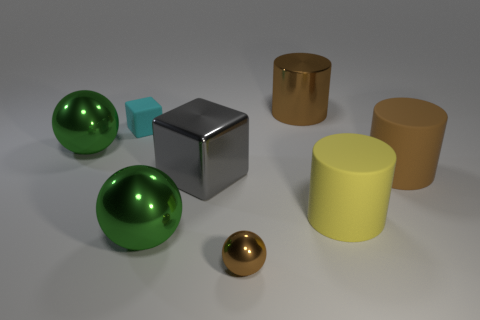Is the big brown cylinder that is in front of the large shiny cylinder made of the same material as the tiny brown thing in front of the tiny rubber object?
Your answer should be very brief. No. There is a large cylinder behind the thing right of the yellow object; what is it made of?
Offer a terse response. Metal. There is a large sphere that is in front of the brown rubber cylinder; what is its material?
Provide a short and direct response. Metal. How many large green objects are the same shape as the big gray shiny thing?
Your answer should be compact. 0. Is the color of the big metal cylinder the same as the small metallic thing?
Make the answer very short. Yes. What material is the yellow cylinder that is to the right of the brown metallic object that is on the left side of the brown shiny object that is to the right of the small brown thing made of?
Ensure brevity in your answer.  Rubber. Are there any big green shiny balls left of the small brown metal sphere?
Make the answer very short. Yes. What is the shape of the gray shiny object that is the same size as the brown metal cylinder?
Provide a short and direct response. Cube. Is the large yellow cylinder made of the same material as the small sphere?
Your answer should be compact. No. How many metallic things are either cyan objects or big cyan cylinders?
Ensure brevity in your answer.  0. 